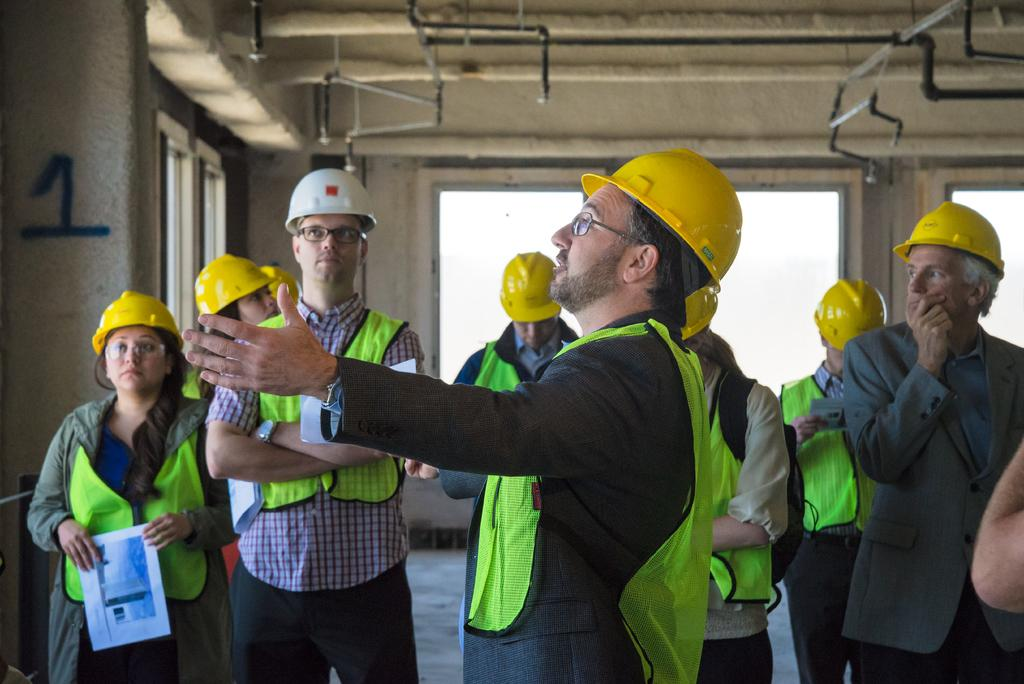How many people are in the image? There is a group of people in the image, but the exact number is not specified. What are the people wearing on their heads? The people are wearing helmets. Where are the people standing in the image? The people are standing on the floor. What can be seen in the background of the image? There are windows and rods in the background of the image. Is there a cart being used to measure the rainstorm in the image? There is no mention of a cart, measuring, or a rainstorm in the image. 